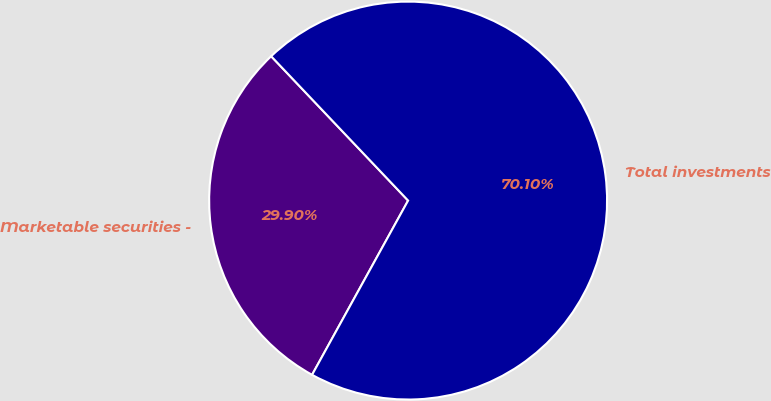Convert chart. <chart><loc_0><loc_0><loc_500><loc_500><pie_chart><fcel>Marketable securities -<fcel>Total investments<nl><fcel>29.9%<fcel>70.1%<nl></chart> 